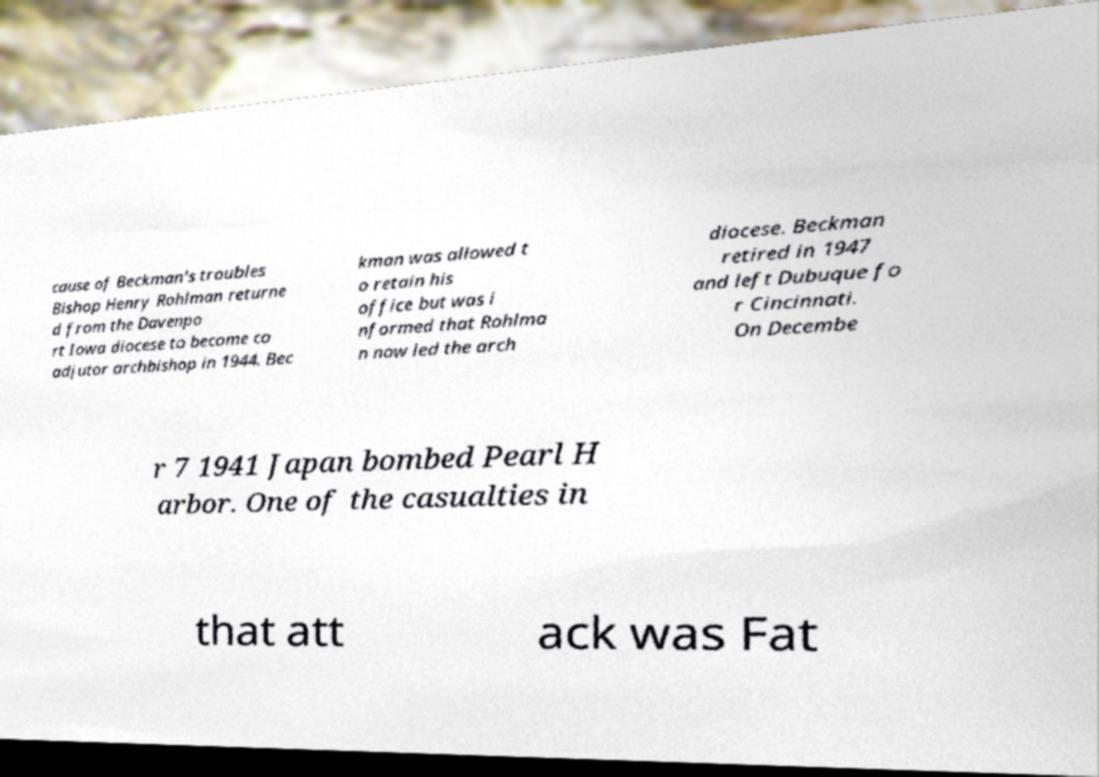Can you accurately transcribe the text from the provided image for me? cause of Beckman's troubles Bishop Henry Rohlman returne d from the Davenpo rt Iowa diocese to become co adjutor archbishop in 1944. Bec kman was allowed t o retain his office but was i nformed that Rohlma n now led the arch diocese. Beckman retired in 1947 and left Dubuque fo r Cincinnati. On Decembe r 7 1941 Japan bombed Pearl H arbor. One of the casualties in that att ack was Fat 